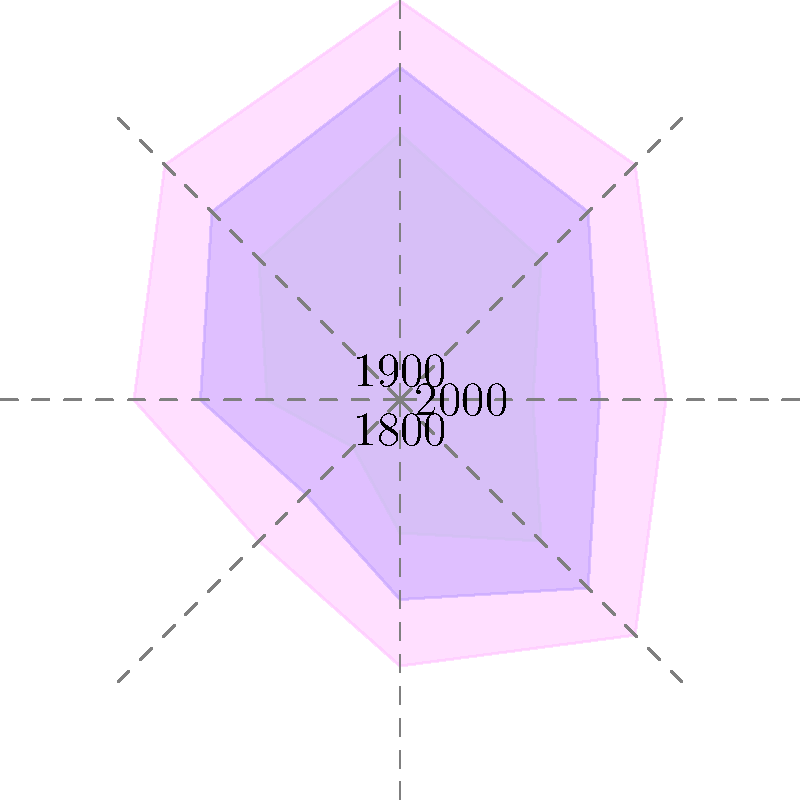The polar area diagram above represents the evolution of Omani tribal territories over three centuries. Which direction shows the most significant expansion of tribal territory from 1800 to 2000? To determine the direction of most significant expansion, we need to analyze the changes in each direction from 1800 to 2000:

1. The innermost area (pale green) represents tribal territories in 1800.
2. The middle area (light blue) represents tribal territories in 1900.
3. The outermost area (pink) represents tribal territories in 2000.

Let's examine each direction:

1. North (90°): Expansion from 4 to 5 to 6 units
2. Northeast (45°): Expansion from 3 to 4 to 5 units
3. East (0°): Expansion from 2 to 3 to 4 units
4. Southeast (315°): Expansion from 3 to 4 to 5 units
5. South (270°): Expansion from 2 to 3 to 4 units
6. Southwest (225°): Expansion from 1 to 2 to 3 units
7. West (180°): Expansion from 2 to 3 to 4 units
8. Northwest (135°): Expansion from 3 to 4 to 5 units

The direction with the largest total increase from 1800 to 2000 is the North (90°), showing an expansion of 2 units (from 4 to 6).
Answer: North 